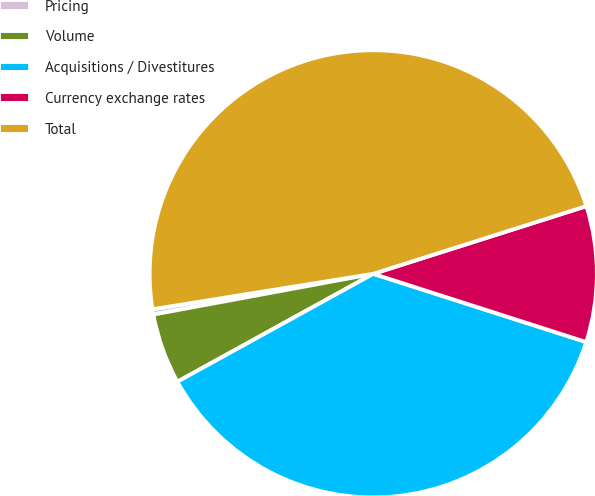Convert chart to OTSL. <chart><loc_0><loc_0><loc_500><loc_500><pie_chart><fcel>Pricing<fcel>Volume<fcel>Acquisitions / Divestitures<fcel>Currency exchange rates<fcel>Total<nl><fcel>0.38%<fcel>5.1%<fcel>37.05%<fcel>9.83%<fcel>47.64%<nl></chart> 